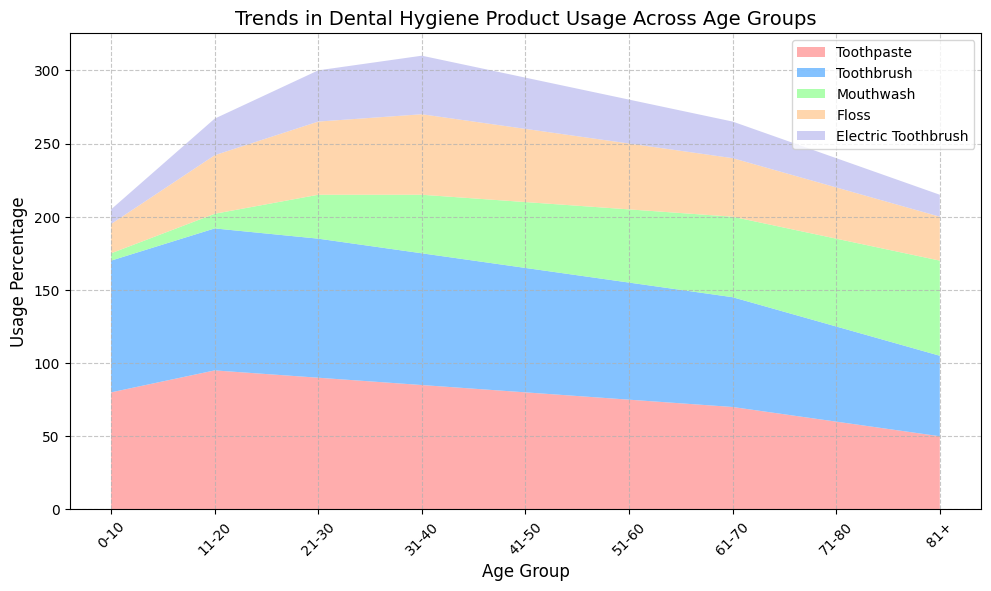What age group has the highest usage of toothpaste? To determine which age group has the highest toothpaste usage, refer to the area representing toothpaste in the chart and identify the age group at the peak of this area.
Answer: 11-20 Which dental hygiene product has the greatest increase in usage between the age groups 0-10 and 81+? Compare the usage percentages for each product between the age groups 0-10 and 81+. Calculate the difference for each product. The product with the largest difference in percentages is the answer.
Answer: Mouthwash What is the difference in floss usage between the 21-30 and 71-80 age groups? Look at the floss usage percentages for the age groups 21-30 and 71-80. Subtract the floss usage of the 71-80 age group from the floss usage of the 21-30 age group (50 - 35).
Answer: 15 Which age group shows the least interest in electric toothbrushes? Identify the age group with the smallest area representing electric toothbrushes in the chart.
Answer: 81+ Between which age groups does toothpaste usage decline the most sharply? Examine the slope or steepness of the areas representing toothpaste between the consecutive age groups. Look for the section where the toothpaste usage drops most dramatically.
Answer: 11-20 to 21-30 What two products have the closest usage percentage in the 31-40 age group? Compare the usage percentages of all the products in the 31-40 age group. Identify the two products with the smallest difference in their percentages.
Answer: Toothbrush and Electric Toothbrush Which product's usage is more prevalent in older age groups (61+) compared to younger age groups (<51)? Analyze the usage trends of each product shown in the chart. Determine which product's area grows larger as the age groups increase beyond 51.
Answer: Mouthwash What is the trend in floss usage from age group 41-50 to 81+? Examine the area representing floss from age group 41-50 to 81+ and describe whether it increases, decreases, or remains constant.
Answer: Decreases How does the usage of mouthwash change from age group 21-30 to 81+? Trace the area representing mouthwash from the age group 21-30 to 81+. Determine whether the trend shows an increase, decrease, or is inconsistent.
Answer: Increases What percentage of people aged 11-20 use electric toothbrushes? Locate the area representing electric toothbrushes in the age group 11-20. Read off the percentage value from the chart.
Answer: 25 